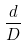<formula> <loc_0><loc_0><loc_500><loc_500>\frac { d } { D }</formula> 